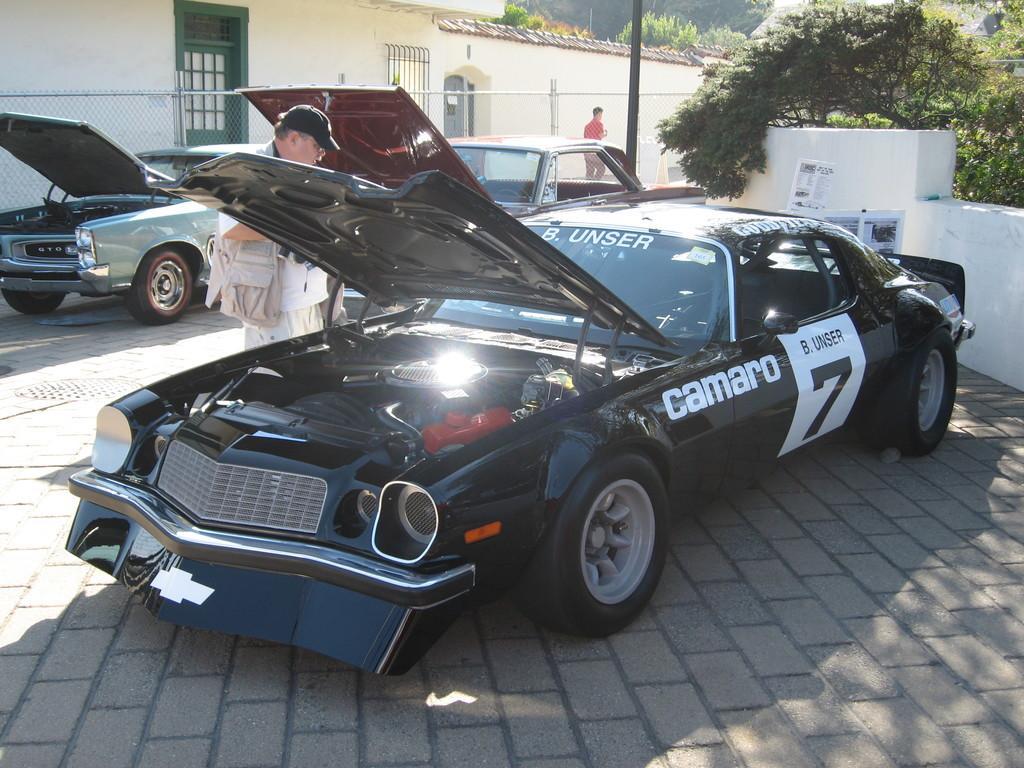Could you give a brief overview of what you see in this image? In this image there are cars parked on the ground. There are numbers and text on the cars. The bonnet of the cars is open. There are people standing beside the cars. In the background there are houses and a pole. At the top there are trees. 